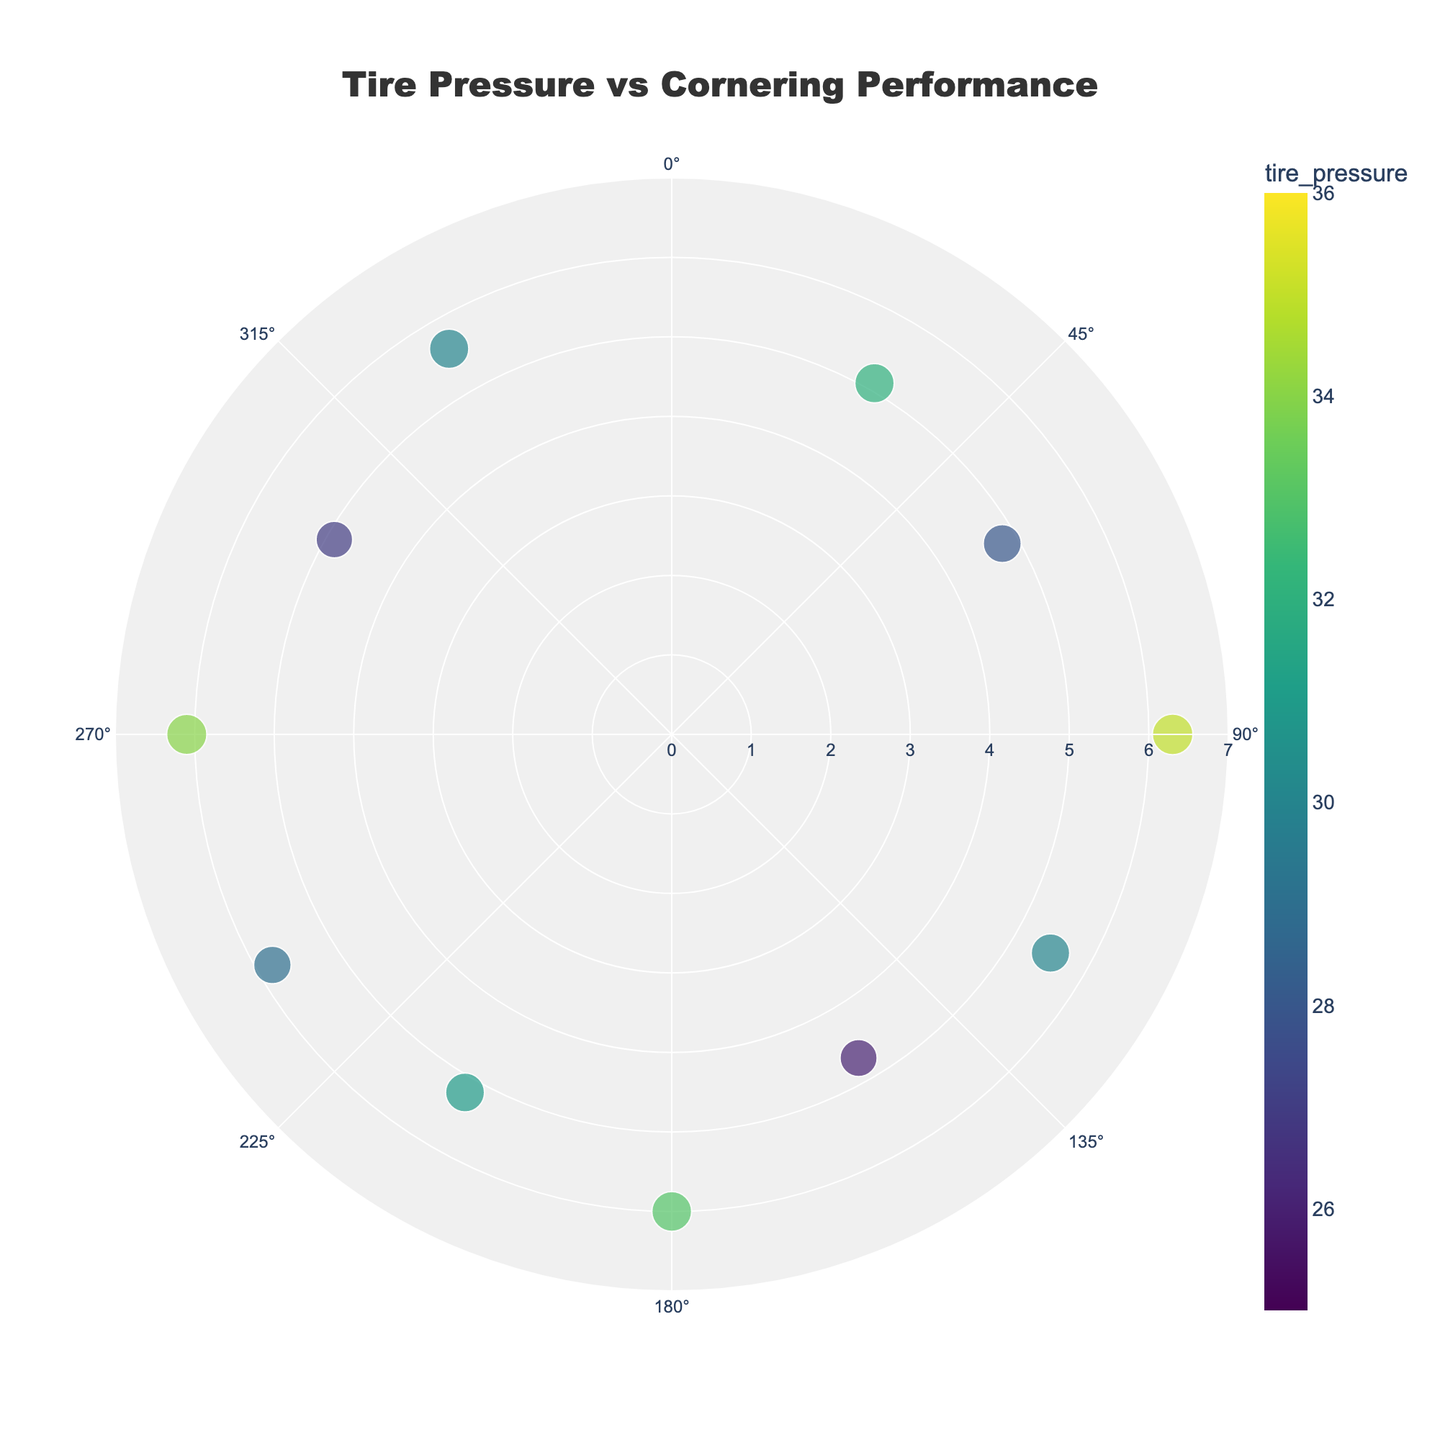What is the title of the plot? The title can be found at the top center of the chart. It reads "Tire Pressure vs Cornering Performance".
Answer: Tire Pressure vs Cornering Performance How many riders are included in the plot? Each dot on the polar scatter plot represents a rider. By counting the total number of dots, we see there are 10 riders.
Answer: 10 Which rider has the highest cornering speed? By looking at the size of the dots, bigger dots indicate higher cornering speeds. Identifying the largest dot and checking the hover information, we see that Tina White, with a cornering speed of 48 mph, is the one.
Answer: Tina White What are the weather conditions experienced during the data collection? Using the hover information on each dot, we can collect the weather conditions, which include Sunny, Cloudy, Rainy, and Foggy.
Answer: Sunny, Cloudy, Rainy, Foggy Which rider recorded the highest tire pressure, and what was it? The color scale represents tire pressure. By identifying the darkest dot indicative of the highest PSI and checking the hover information, Emily Johnson recorded 35 PSI.
Answer: Emily Johnson, 35 PSI How many riders maneuvered more than ten corners? By checking hover information for the 'Corners Maneuvered' attribute, riders who have more than ten corners include Mark Brown, Luke Wilson, Tina White, and Amelia Clark. There are 4 such riders.
Answer: 4 Which weather condition had the highest average cornering speed? For each weather condition, average the cornering speeds from hover information: 
- Sunny (45 + 46 + 47 + 45)/4 = 45.75 mph
- Cloudy (48 + 41)/2 = 44.5 mph
- Rainy (43 + 39)/2 = 41 mph
- Foggy (40 + 44)/2 = 42 mph
Sunny has the highest average cornering speed.
Answer: Sunny Who maneuvered the most corners under foggy conditions, and how many corners were maneuvered? By checking dots labeled with 'Foggy' weather condition and comparing 'Corners Maneuvered', Daniel Lopez maneuvered 9 corners, which is the highest under Foggy conditions.
Answer: Daniel Lopez, 9 What is the average tire pressure of all riders? Sum up all the tire pressures and divide by the total number of riders:
(32 + 28 + 35 + 30 + 26 + 33 + 31 + 29 + 34 + 27 + 30) / 11 = 30.6 PSI
Answer: 30.6 PSI Which angle corresponds to the longest distance, and what is that distance? The radial distance from the center represents the 'distance' attribute. The dot at an angle of 90° shows the maximum radial distance, which is 6.3.
Answer: 90°, 6.3 